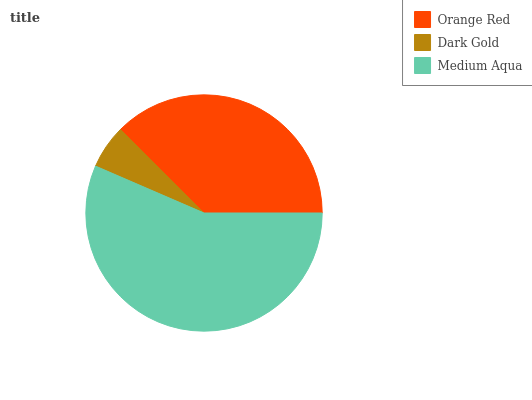Is Dark Gold the minimum?
Answer yes or no. Yes. Is Medium Aqua the maximum?
Answer yes or no. Yes. Is Medium Aqua the minimum?
Answer yes or no. No. Is Dark Gold the maximum?
Answer yes or no. No. Is Medium Aqua greater than Dark Gold?
Answer yes or no. Yes. Is Dark Gold less than Medium Aqua?
Answer yes or no. Yes. Is Dark Gold greater than Medium Aqua?
Answer yes or no. No. Is Medium Aqua less than Dark Gold?
Answer yes or no. No. Is Orange Red the high median?
Answer yes or no. Yes. Is Orange Red the low median?
Answer yes or no. Yes. Is Medium Aqua the high median?
Answer yes or no. No. Is Dark Gold the low median?
Answer yes or no. No. 